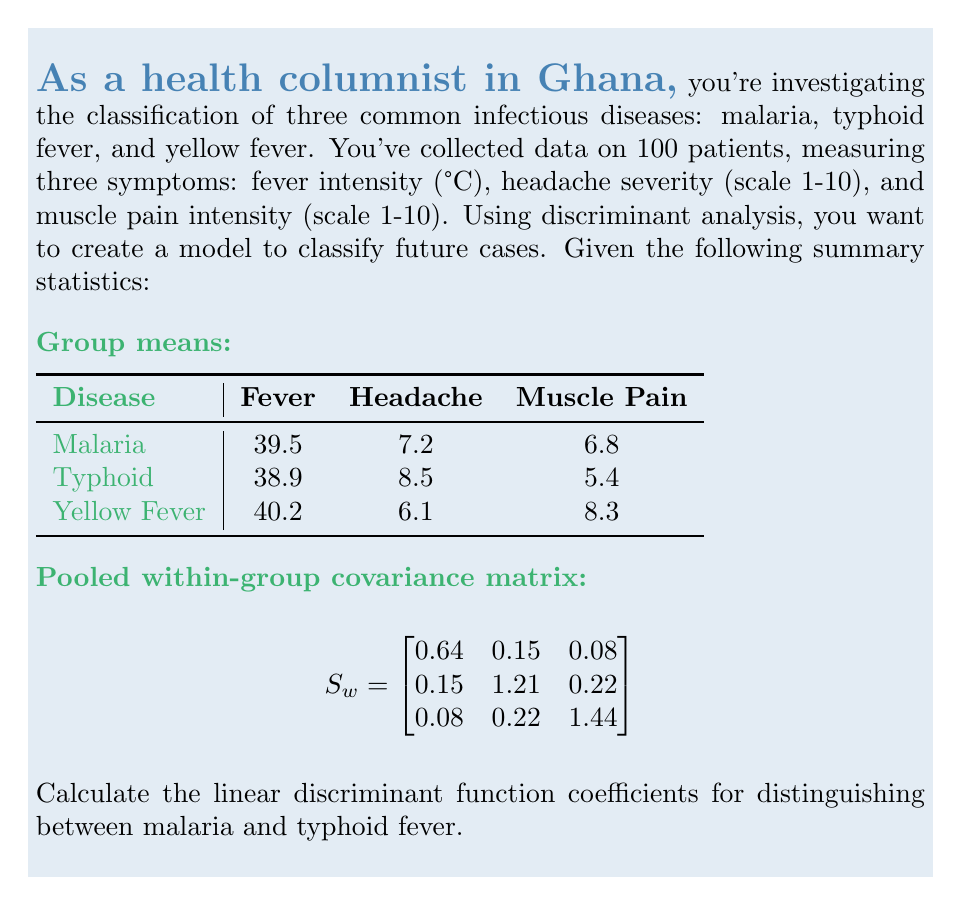Show me your answer to this math problem. To calculate the linear discriminant function coefficients, we'll follow these steps:

1) The linear discriminant function between two groups is given by:
   $$a = S_w^{-1}(\bar{x}_1 - \bar{x}_2)$$
   where $S_w^{-1}$ is the inverse of the pooled within-group covariance matrix, and $\bar{x}_1$ and $\bar{x}_2$ are the mean vectors for the two groups.

2) First, we need to find $S_w^{-1}$. Using a matrix calculator, we get:
   $$S_w^{-1} = \begin{bmatrix}
   1.6129 & -0.1935 & -0.0403 \\
   -0.1935 & 0.8871 & -0.1290 \\
   -0.0403 & -0.1290 & 0.7258
   \end{bmatrix}$$

3) Next, we calculate the difference between the mean vectors:
   $$\bar{x}_1 - \bar{x}_2 = \begin{bmatrix}
   39.5 \\
   7.2 \\
   6.8
   \end{bmatrix} - \begin{bmatrix}
   38.9 \\
   8.5 \\
   5.4
   \end{bmatrix} = \begin{bmatrix}
   0.6 \\
   -1.3 \\
   1.4
   \end{bmatrix}$$

4) Now, we multiply $S_w^{-1}$ by $(\bar{x}_1 - \bar{x}_2)$:
   $$a = \begin{bmatrix}
   1.6129 & -0.1935 & -0.0403 \\
   -0.1935 & 0.8871 & -0.1290 \\
   -0.0403 & -0.1290 & 0.7258
   \end{bmatrix} \begin{bmatrix}
   0.6 \\
   -1.3 \\
   1.4
   \end{bmatrix}$$

5) Performing the matrix multiplication:
   $$a = \begin{bmatrix}
   0.7258 \\
   -1.5484 \\
   0.9677
   \end{bmatrix}$$

These are the linear discriminant function coefficients for distinguishing between malaria and typhoid fever.
Answer: $a = (0.7258, -1.5484, 0.9677)$ 